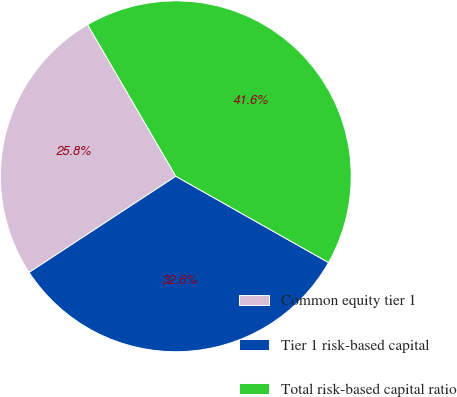Convert chart. <chart><loc_0><loc_0><loc_500><loc_500><pie_chart><fcel>Common equity tier 1<fcel>Tier 1 risk-based capital<fcel>Total risk-based capital ratio<nl><fcel>25.84%<fcel>32.58%<fcel>41.57%<nl></chart> 